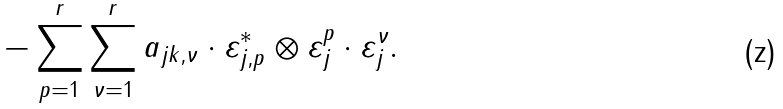Convert formula to latex. <formula><loc_0><loc_0><loc_500><loc_500>- \sum _ { p = 1 } ^ { r } \sum _ { \nu = 1 } ^ { r } a _ { j k , \nu } \cdot \varepsilon _ { j , p } ^ { * } \otimes \varepsilon _ { j } ^ { p } \cdot \varepsilon _ { j } ^ { \nu } .</formula> 